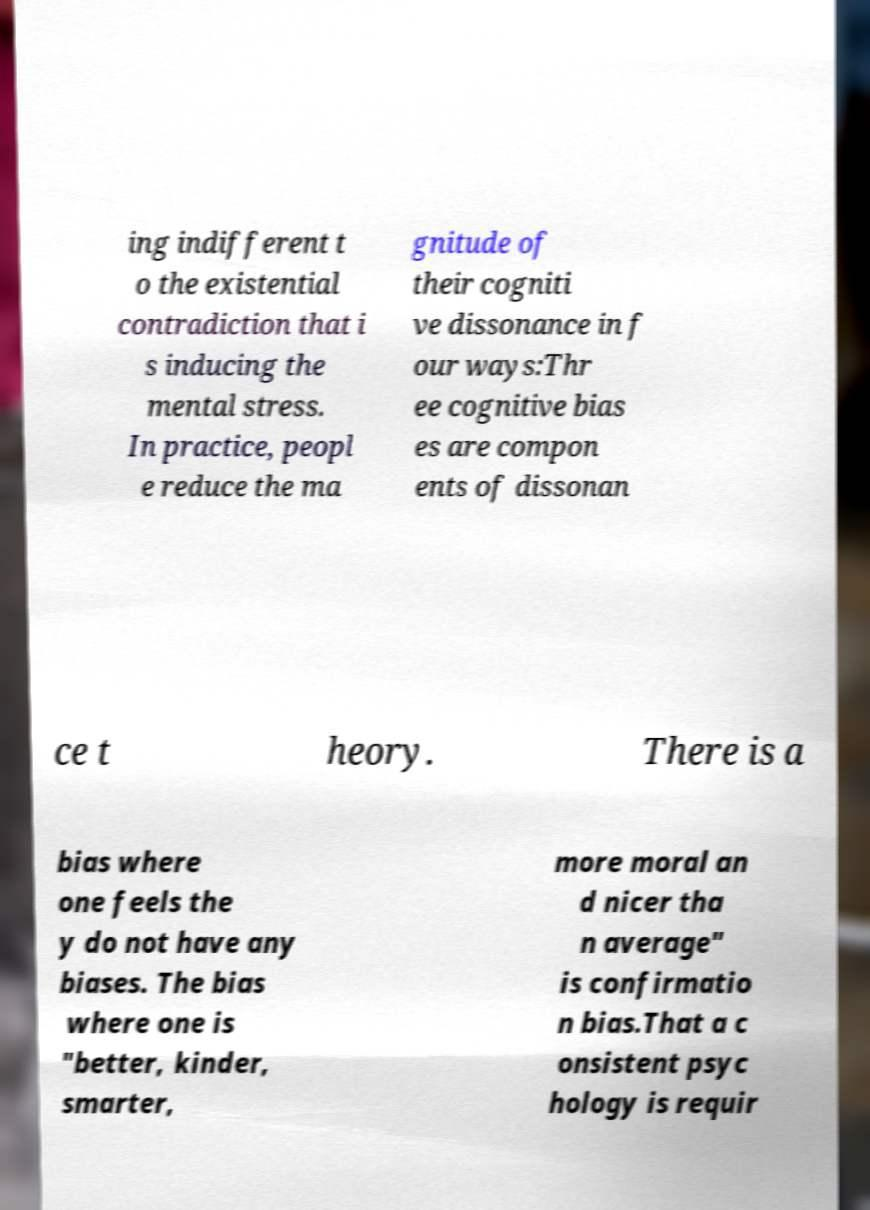For documentation purposes, I need the text within this image transcribed. Could you provide that? ing indifferent t o the existential contradiction that i s inducing the mental stress. In practice, peopl e reduce the ma gnitude of their cogniti ve dissonance in f our ways:Thr ee cognitive bias es are compon ents of dissonan ce t heory. There is a bias where one feels the y do not have any biases. The bias where one is "better, kinder, smarter, more moral an d nicer tha n average" is confirmatio n bias.That a c onsistent psyc hology is requir 